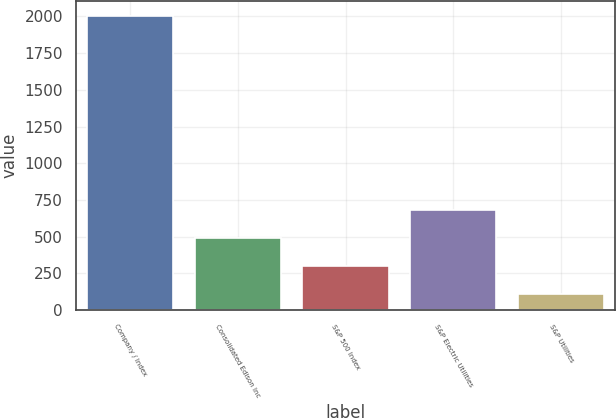<chart> <loc_0><loc_0><loc_500><loc_500><bar_chart><fcel>Company / Index<fcel>Consolidated Edison Inc<fcel>S&P 500 Index<fcel>S&P Electric Utilities<fcel>S&P Utilities<nl><fcel>2004<fcel>488.68<fcel>299.26<fcel>678.1<fcel>109.85<nl></chart> 